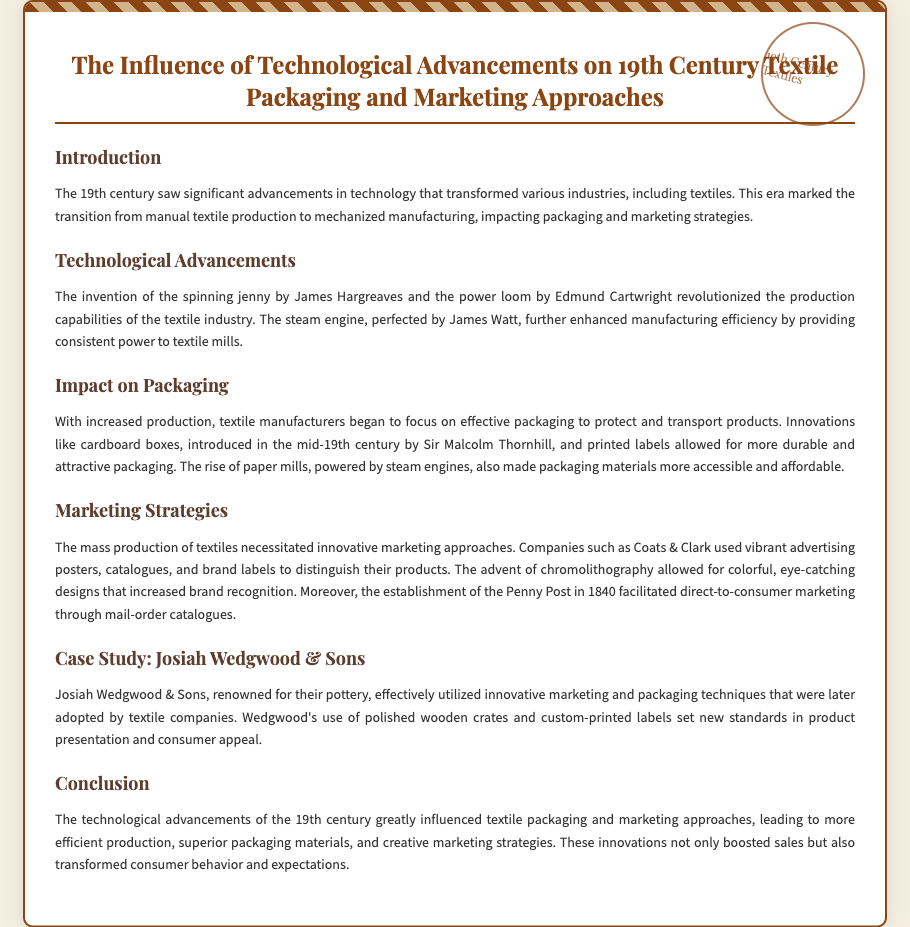What invention revolutionized production capabilities? The document states that the spinning jenny by James Hargreaves and the power loom by Edmund Cartwright revolutionized production capabilities.
Answer: Spinning jenny What material was introduced for packaging in the mid-19th century? The document mentions that cardboard boxes were introduced in the mid-19th century by Sir Malcolm Thornhill for packaging.
Answer: Cardboard boxes Who utilized vibrant advertising techniques in the textile industry? The document provides information that companies like Coats & Clark used vibrant advertising posters for marketing their textile products.
Answer: Coats & Clark What type of printing technology allowed for colorful designs? The document indicates that the advent of chromolithography allowed for colorful, eye-catching designs in marketing strategies.
Answer: Chromolithography Which company set new standards in product presentation? The case study in the document highlights that Josiah Wedgwood & Sons set new standards in product presentation.
Answer: Josiah Wedgwood & Sons How did the steam engine impact packaging materials? The document explains that the rise of paper mills, powered by steam engines, made packaging materials more accessible and affordable.
Answer: More accessible and affordable What was the effect of mass production on marketing? The document notes that mass production of textiles necessitated innovative marketing approaches.
Answer: Innovative marketing approaches What was a significant technological advancement in the textile industry? The document mentions the perfection of the steam engine by James Watt as a significant technological advancement in the textile industry.
Answer: Steam engine When was the Penny Post established? The document states that the establishment of the Penny Post occurred in 1840, facilitating marketing through mail-order catalogues.
Answer: 1840 